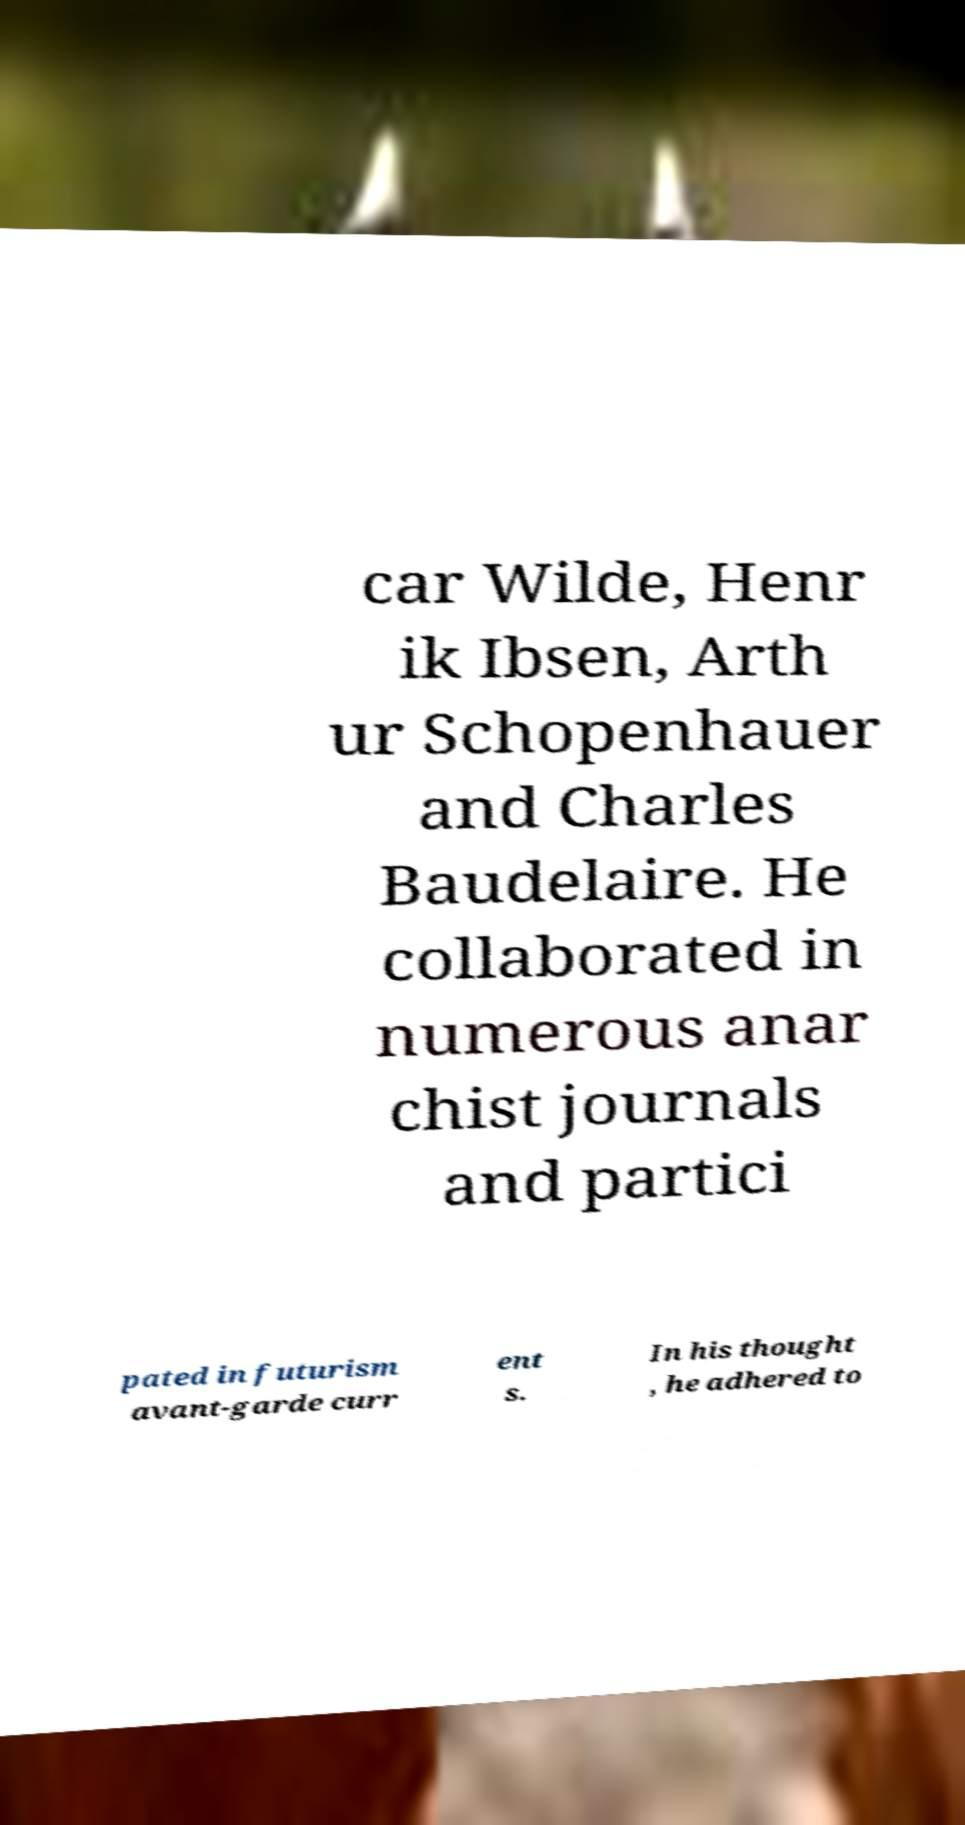Could you assist in decoding the text presented in this image and type it out clearly? car Wilde, Henr ik Ibsen, Arth ur Schopenhauer and Charles Baudelaire. He collaborated in numerous anar chist journals and partici pated in futurism avant-garde curr ent s. In his thought , he adhered to 